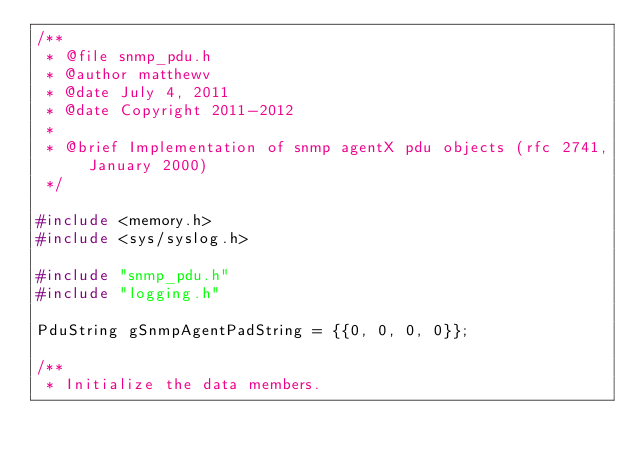Convert code to text. <code><loc_0><loc_0><loc_500><loc_500><_C++_>/**
 * @file snmp_pdu.h
 * @author matthewv
 * @date July 4, 2011
 * @date Copyright 2011-2012
 *
 * @brief Implementation of snmp agentX pdu objects (rfc 2741, January 2000)
 */

#include <memory.h>
#include <sys/syslog.h>

#include "snmp_pdu.h"
#include "logging.h"

PduString gSnmpAgentPadString = {{0, 0, 0, 0}};

/**
 * Initialize the data members.</code> 